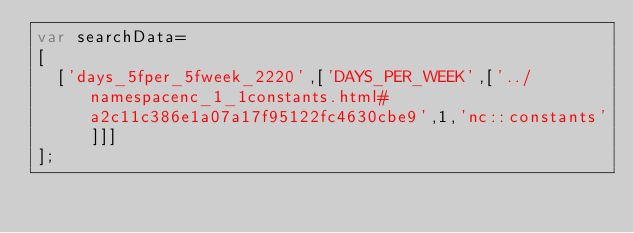Convert code to text. <code><loc_0><loc_0><loc_500><loc_500><_JavaScript_>var searchData=
[
  ['days_5fper_5fweek_2220',['DAYS_PER_WEEK',['../namespacenc_1_1constants.html#a2c11c386e1a07a17f95122fc4630cbe9',1,'nc::constants']]]
];
</code> 